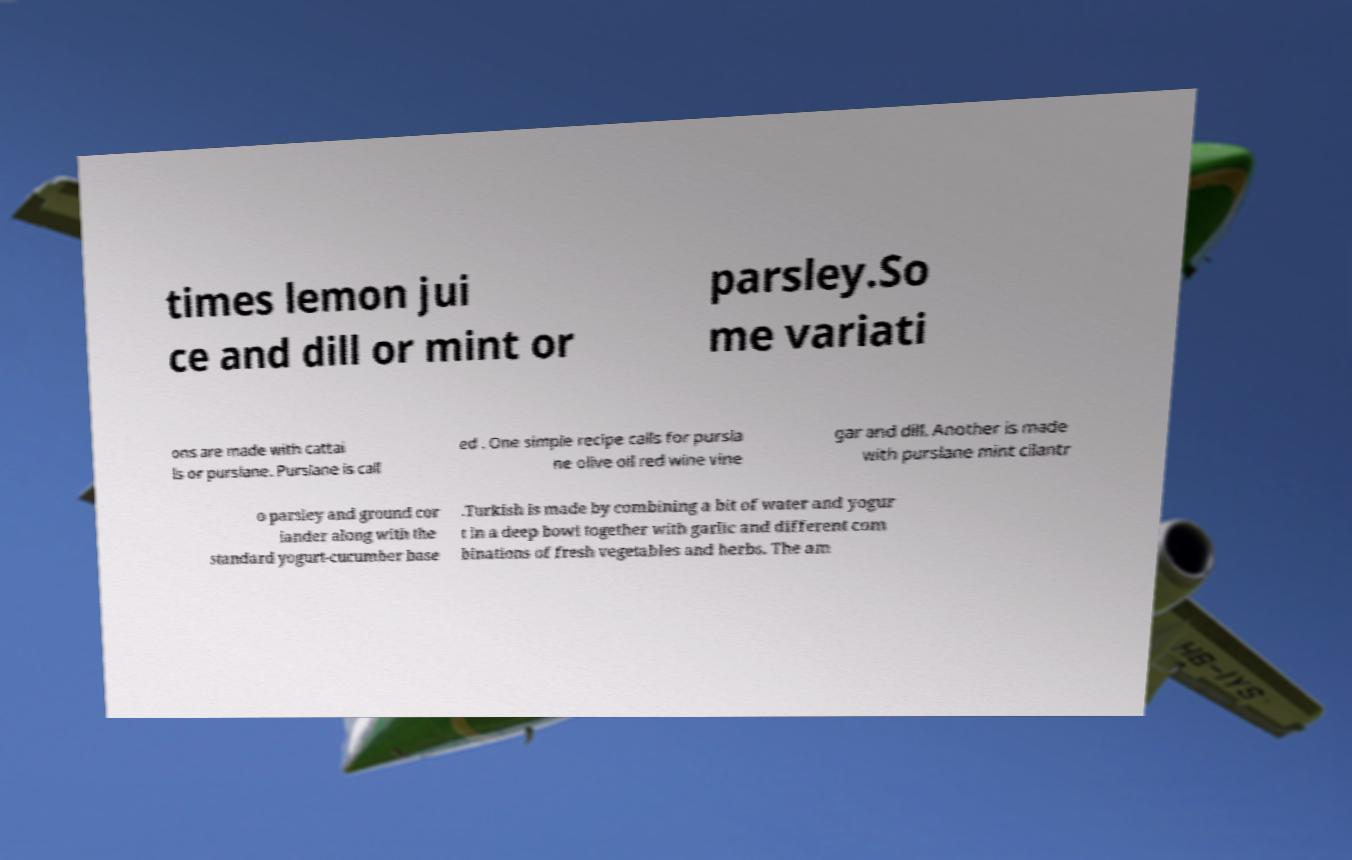Please identify and transcribe the text found in this image. times lemon jui ce and dill or mint or parsley.So me variati ons are made with cattai ls or purslane. Purslane is call ed . One simple recipe calls for pursla ne olive oil red wine vine gar and dill. Another is made with purslane mint cilantr o parsley and ground cor iander along with the standard yogurt-cucumber base .Turkish is made by combining a bit of water and yogur t in a deep bowl together with garlic and different com binations of fresh vegetables and herbs. The am 